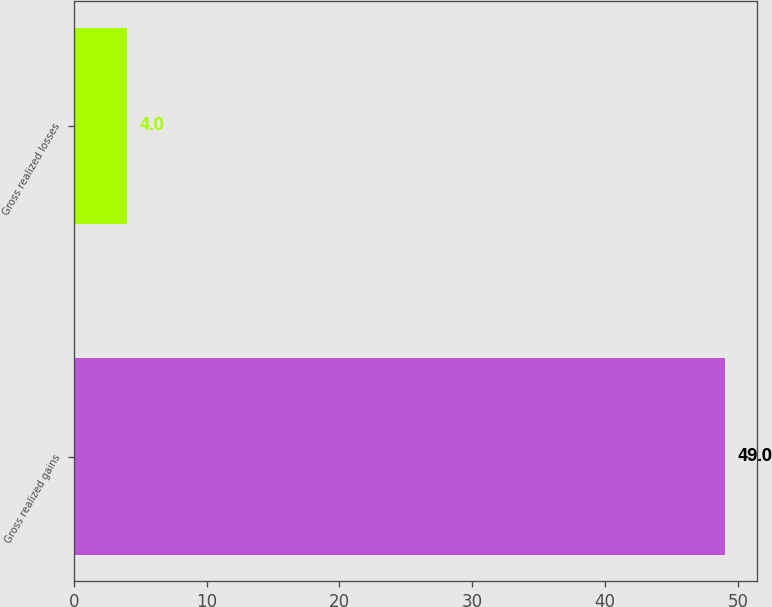<chart> <loc_0><loc_0><loc_500><loc_500><bar_chart><fcel>Gross realized gains<fcel>Gross realized losses<nl><fcel>49<fcel>4<nl></chart> 